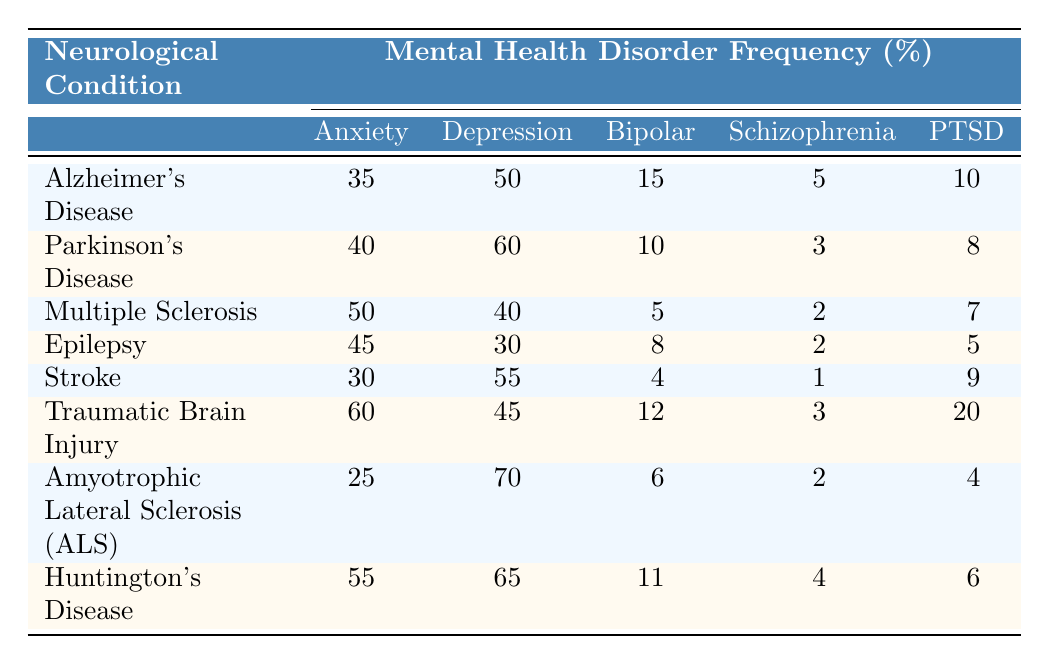What is the frequency of depression among patients with Alzheimer's Disease? The table shows that the frequency of depression disorder for Alzheimer's Disease is 50%.
Answer: 50% Which neurological condition has the highest frequency of anxiety disorders? According to the table, Traumatic Brain Injury has the highest frequency at 60%.
Answer: 60% What is the frequency of schizophrenia in Parkinson's Disease? The table indicates that the frequency of schizophrenia in Parkinson's Disease is 3%.
Answer: 3% Which neurological condition has the lowest frequency of bipolar disorder? The table reveals that Multiple Sclerosis has the lowest frequency of bipolar disorder at 5%.
Answer: 5% Is the frequency of PTSD higher in Epilepsy than in Stroke? By comparing the values, PTSD in Epilepsy is 5% and in Stroke is 9%, making the statement false.
Answer: No What is the total frequency of anxiety disorders across all listed neurological conditions? To find the total frequency, we sum the anxiety disorder frequencies: 35 + 40 + 50 + 45 + 30 + 60 + 25 + 55 = 390%.
Answer: 390% What is the average frequency of depression disorder for all neurological conditions? The total frequency of depression is 50 + 60 + 40 + 30 + 55 + 45 + 70 + 65 = 415%, and dividing by 8 conditions gives an average of 51.875%.
Answer: Approximately 51.88% Which neurological condition has the highest co-occurring frequency of PTSD? Looking at the table, Traumatic Brain Injury has the highest frequency of PTSD at 20%.
Answer: 20% Is the frequency of anxiety disorders in Huntington's Disease greater than that in Alzheimer's Disease? The anxiety frequency for Huntington's Disease is 55%, while for Alzheimer's Disease it is 35%, making the statement true.
Answer: Yes What is the difference in depression disorder frequency between Traumatic Brain Injury and Amyotrophic Lateral Sclerosis (ALS)? The frequency for Traumatic Brain Injury is 45% and for ALS is 70%. The difference is 70 - 45 = 25%.
Answer: 25% 